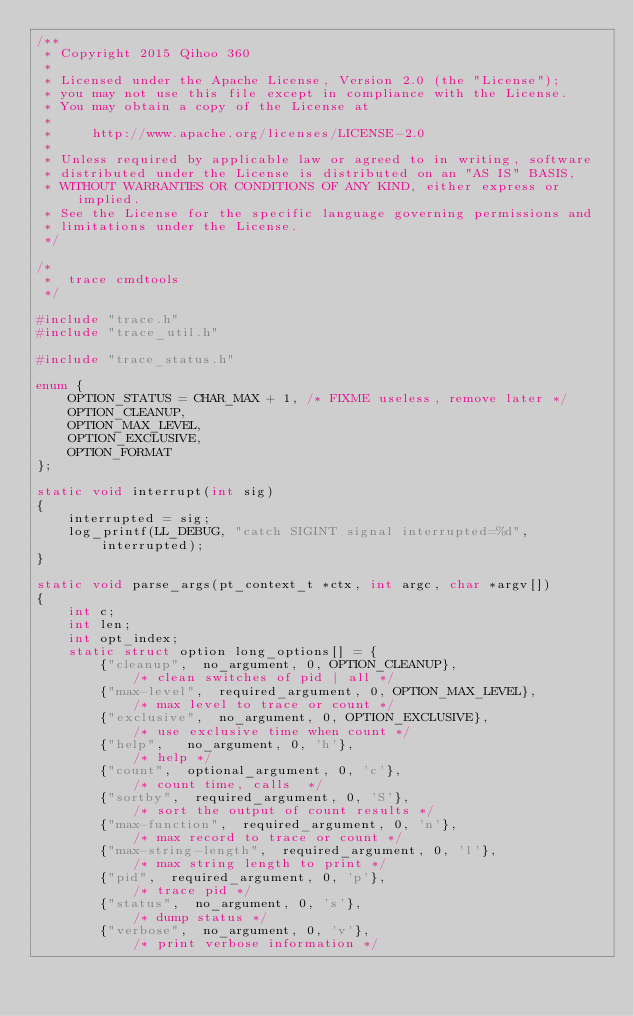<code> <loc_0><loc_0><loc_500><loc_500><_C_>/**
 * Copyright 2015 Qihoo 360
 *
 * Licensed under the Apache License, Version 2.0 (the "License");
 * you may not use this file except in compliance with the License.
 * You may obtain a copy of the License at
 *
 *     http://www.apache.org/licenses/LICENSE-2.0
 *
 * Unless required by applicable law or agreed to in writing, software
 * distributed under the License is distributed on an "AS IS" BASIS,
 * WITHOUT WARRANTIES OR CONDITIONS OF ANY KIND, either express or implied.
 * See the License for the specific language governing permissions and
 * limitations under the License.
 */

/*
 *  trace cmdtools
 */

#include "trace.h"
#include "trace_util.h"

#include "trace_status.h"

enum {
    OPTION_STATUS = CHAR_MAX + 1, /* FIXME useless, remove later */
    OPTION_CLEANUP,
    OPTION_MAX_LEVEL,
    OPTION_EXCLUSIVE,
    OPTION_FORMAT
};

static void interrupt(int sig)
{
    interrupted = sig;
    log_printf(LL_DEBUG, "catch SIGINT signal interrupted=%d", interrupted);
}

static void parse_args(pt_context_t *ctx, int argc, char *argv[])
{
    int c;
    int len;
    int opt_index;
    static struct option long_options[] = {
        {"cleanup",  no_argument, 0, OPTION_CLEANUP},                   /* clean switches of pid | all */
        {"max-level",  required_argument, 0, OPTION_MAX_LEVEL},         /* max level to trace or count */
        {"exclusive",  no_argument, 0, OPTION_EXCLUSIVE},               /* use exclusive time when count */
        {"help",   no_argument, 0, 'h'},                                /* help */
        {"count",  optional_argument, 0, 'c'},                          /* count time, calls  */
        {"sortby",  required_argument, 0, 'S'},                         /* sort the output of count results */
        {"max-function",  required_argument, 0, 'n'},                   /* max record to trace or count */
        {"max-string-length",  required_argument, 0, 'l'},              /* max string length to print */
        {"pid",  required_argument, 0, 'p'},                            /* trace pid */
        {"status",  no_argument, 0, 's'},                               /* dump status */
        {"verbose",  no_argument, 0, 'v'},                              /* print verbose information */</code> 